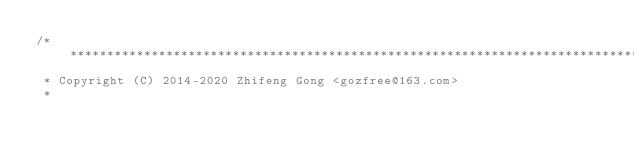Convert code to text. <code><loc_0><loc_0><loc_500><loc_500><_C_>/******************************************************************************
 * Copyright (C) 2014-2020 Zhifeng Gong <gozfree@163.com>
 *</code> 